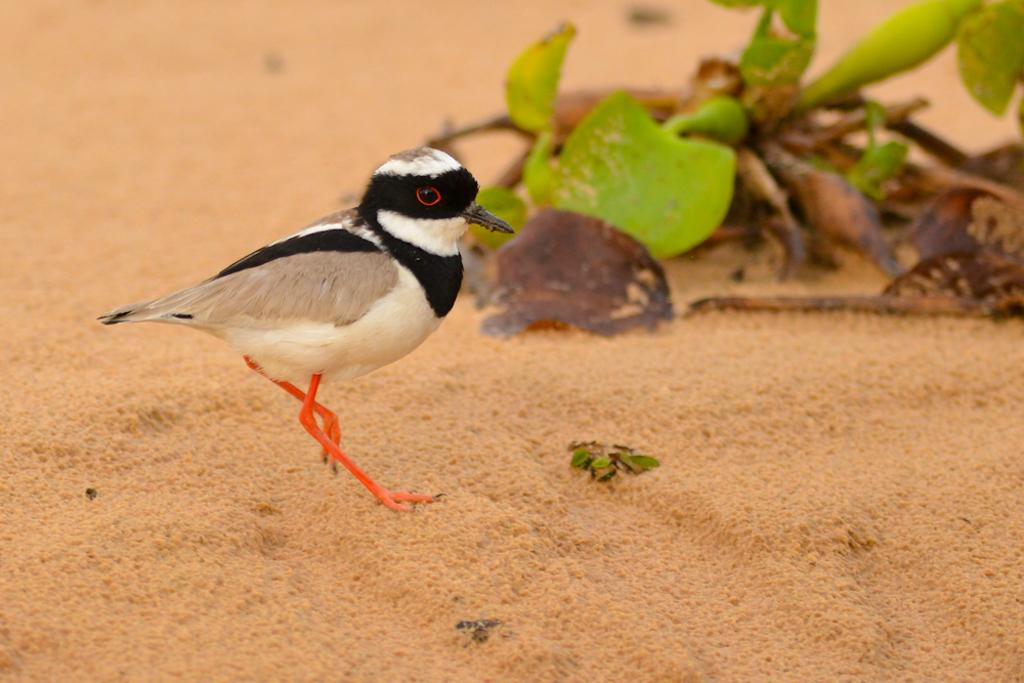What type of animal is on the ground in the image? There is a bird on the ground in the image. What can be seen in the background of the image? There are leaves visible in the background of the image. Are there any spiders crawling on the bird in the image? There is no indication of spiders or any other creatures interacting with the bird in the image. 